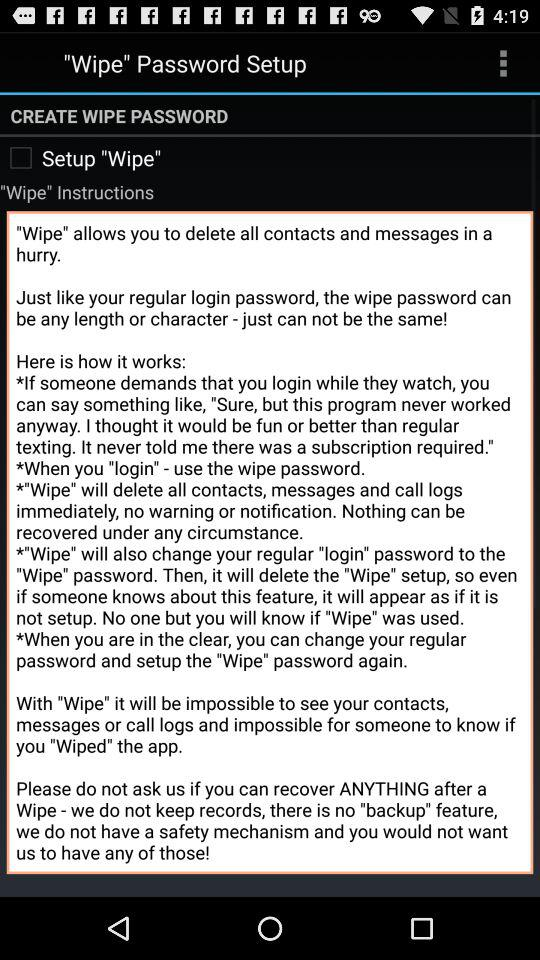Which feature does "Wipe" not provide? "Wipe" does not provide a "backup" feature. 